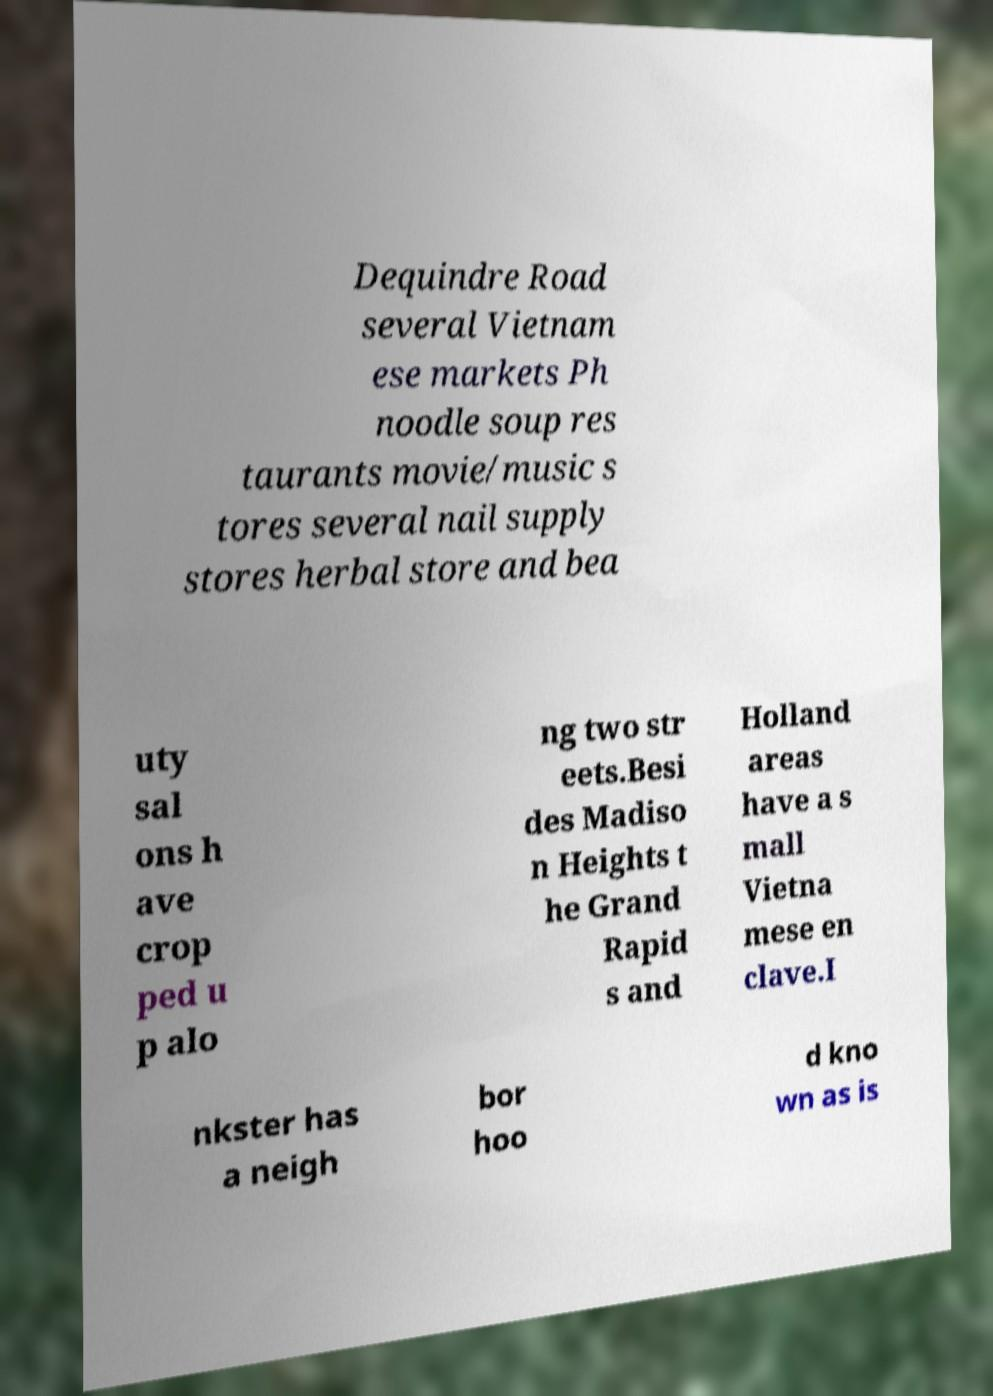Please read and relay the text visible in this image. What does it say? Dequindre Road several Vietnam ese markets Ph noodle soup res taurants movie/music s tores several nail supply stores herbal store and bea uty sal ons h ave crop ped u p alo ng two str eets.Besi des Madiso n Heights t he Grand Rapid s and Holland areas have a s mall Vietna mese en clave.I nkster has a neigh bor hoo d kno wn as is 